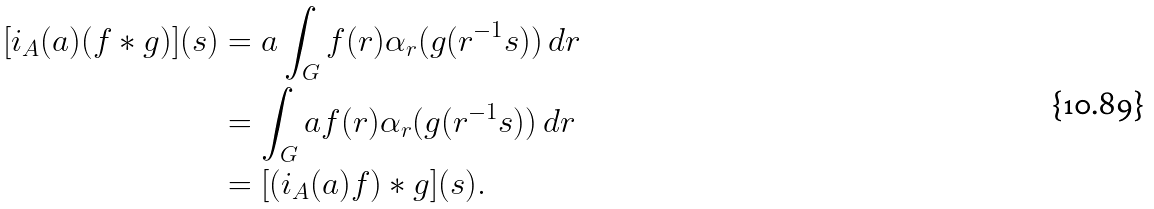Convert formula to latex. <formula><loc_0><loc_0><loc_500><loc_500>[ i _ { A } ( a ) ( f * g ) ] ( s ) & = a \int _ { G } f ( r ) \alpha _ { r } ( g ( r ^ { - 1 } s ) ) \, d r \\ & = \int _ { G } a f ( r ) \alpha _ { r } ( g ( r ^ { - 1 } s ) ) \, d r \\ & = [ ( i _ { A } ( a ) f ) * g ] ( s ) .</formula> 